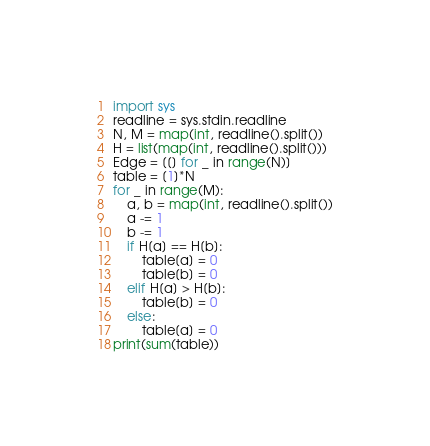<code> <loc_0><loc_0><loc_500><loc_500><_Python_>import sys
readline = sys.stdin.readline
N, M = map(int, readline().split())
H = list(map(int, readline().split()))
Edge = [[] for _ in range(N)]
table = [1]*N
for _ in range(M):
    a, b = map(int, readline().split())
    a -= 1
    b -= 1
    if H[a] == H[b]:
        table[a] = 0
        table[b] = 0
    elif H[a] > H[b]:
        table[b] = 0
    else:
        table[a] = 0
print(sum(table))</code> 